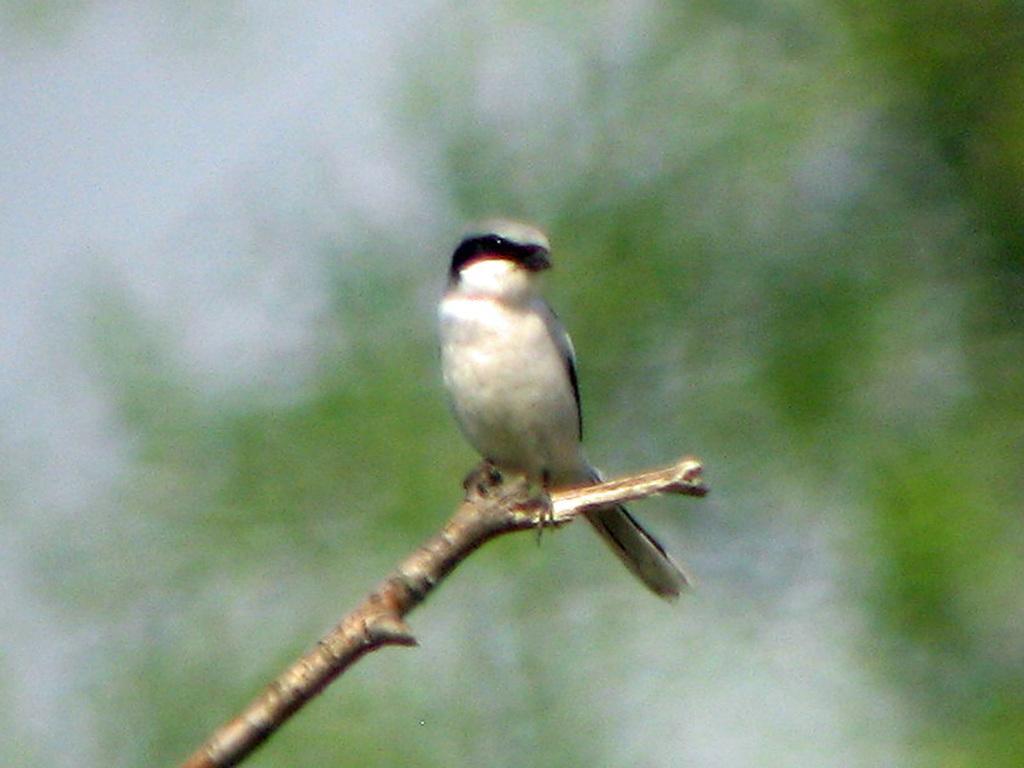How would you summarize this image in a sentence or two? In the center of the image we can see one wood. On the wood,we can see one bird,which is in black and white color. 